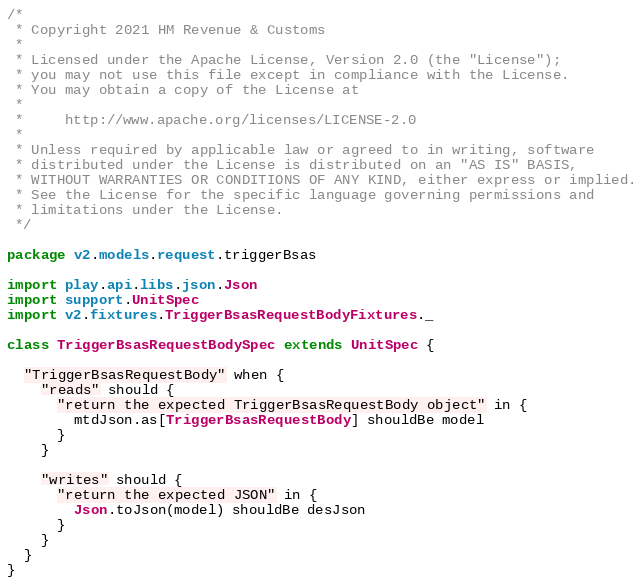<code> <loc_0><loc_0><loc_500><loc_500><_Scala_>/*
 * Copyright 2021 HM Revenue & Customs
 *
 * Licensed under the Apache License, Version 2.0 (the "License");
 * you may not use this file except in compliance with the License.
 * You may obtain a copy of the License at
 *
 *     http://www.apache.org/licenses/LICENSE-2.0
 *
 * Unless required by applicable law or agreed to in writing, software
 * distributed under the License is distributed on an "AS IS" BASIS,
 * WITHOUT WARRANTIES OR CONDITIONS OF ANY KIND, either express or implied.
 * See the License for the specific language governing permissions and
 * limitations under the License.
 */

package v2.models.request.triggerBsas

import play.api.libs.json.Json
import support.UnitSpec
import v2.fixtures.TriggerBsasRequestBodyFixtures._

class TriggerBsasRequestBodySpec extends UnitSpec {

  "TriggerBsasRequestBody" when {
    "reads" should {
      "return the expected TriggerBsasRequestBody object" in {
        mtdJson.as[TriggerBsasRequestBody] shouldBe model
      }
    }

    "writes" should {
      "return the expected JSON" in {
        Json.toJson(model) shouldBe desJson
      }
    }
  }
}
</code> 